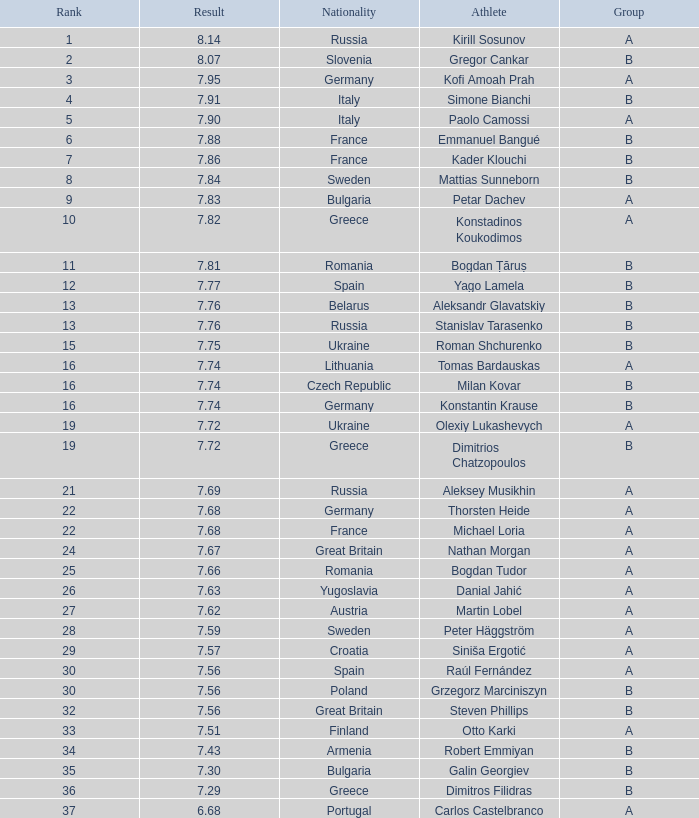Which athlete's rank is more than 15 when the result is less than 7.68, the group is b, and the nationality listed is Great Britain? Steven Phillips. 